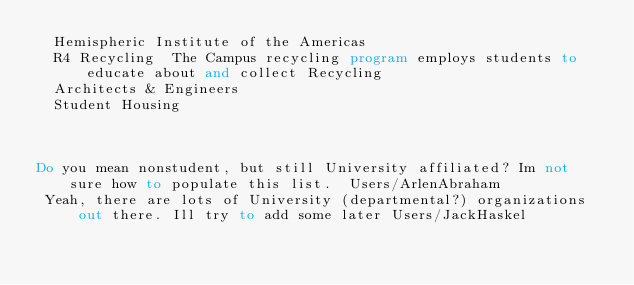Convert code to text. <code><loc_0><loc_0><loc_500><loc_500><_FORTRAN_>  Hemispheric Institute of the Americas
  R4 Recycling  The Campus recycling program employs students to educate about and collect Recycling
  Architects & Engineers
  Student Housing



Do you mean nonstudent, but still University affiliated? Im not sure how to populate this list.  Users/ArlenAbraham
 Yeah, there are lots of University (departmental?) organizations out there. Ill try to add some later Users/JackHaskel
</code> 